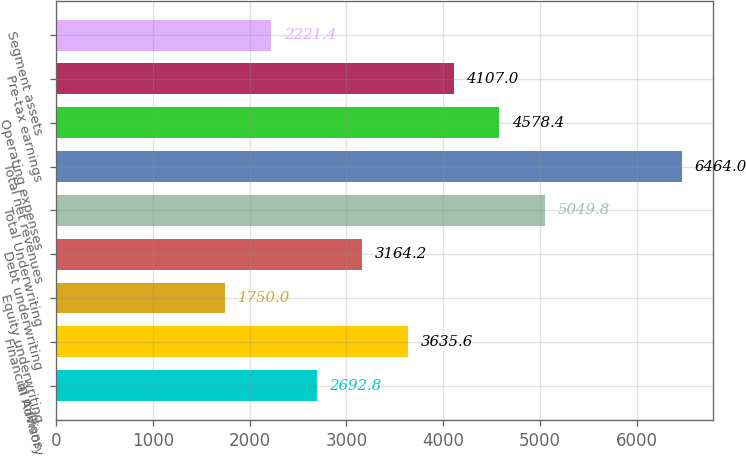Convert chart to OTSL. <chart><loc_0><loc_0><loc_500><loc_500><bar_chart><fcel>in millions<fcel>Financial Advisory<fcel>Equity underwriting<fcel>Debt underwriting<fcel>Total Underwriting<fcel>Total net revenues<fcel>Operating expenses<fcel>Pre-tax earnings<fcel>Segment assets<nl><fcel>2692.8<fcel>3635.6<fcel>1750<fcel>3164.2<fcel>5049.8<fcel>6464<fcel>4578.4<fcel>4107<fcel>2221.4<nl></chart> 